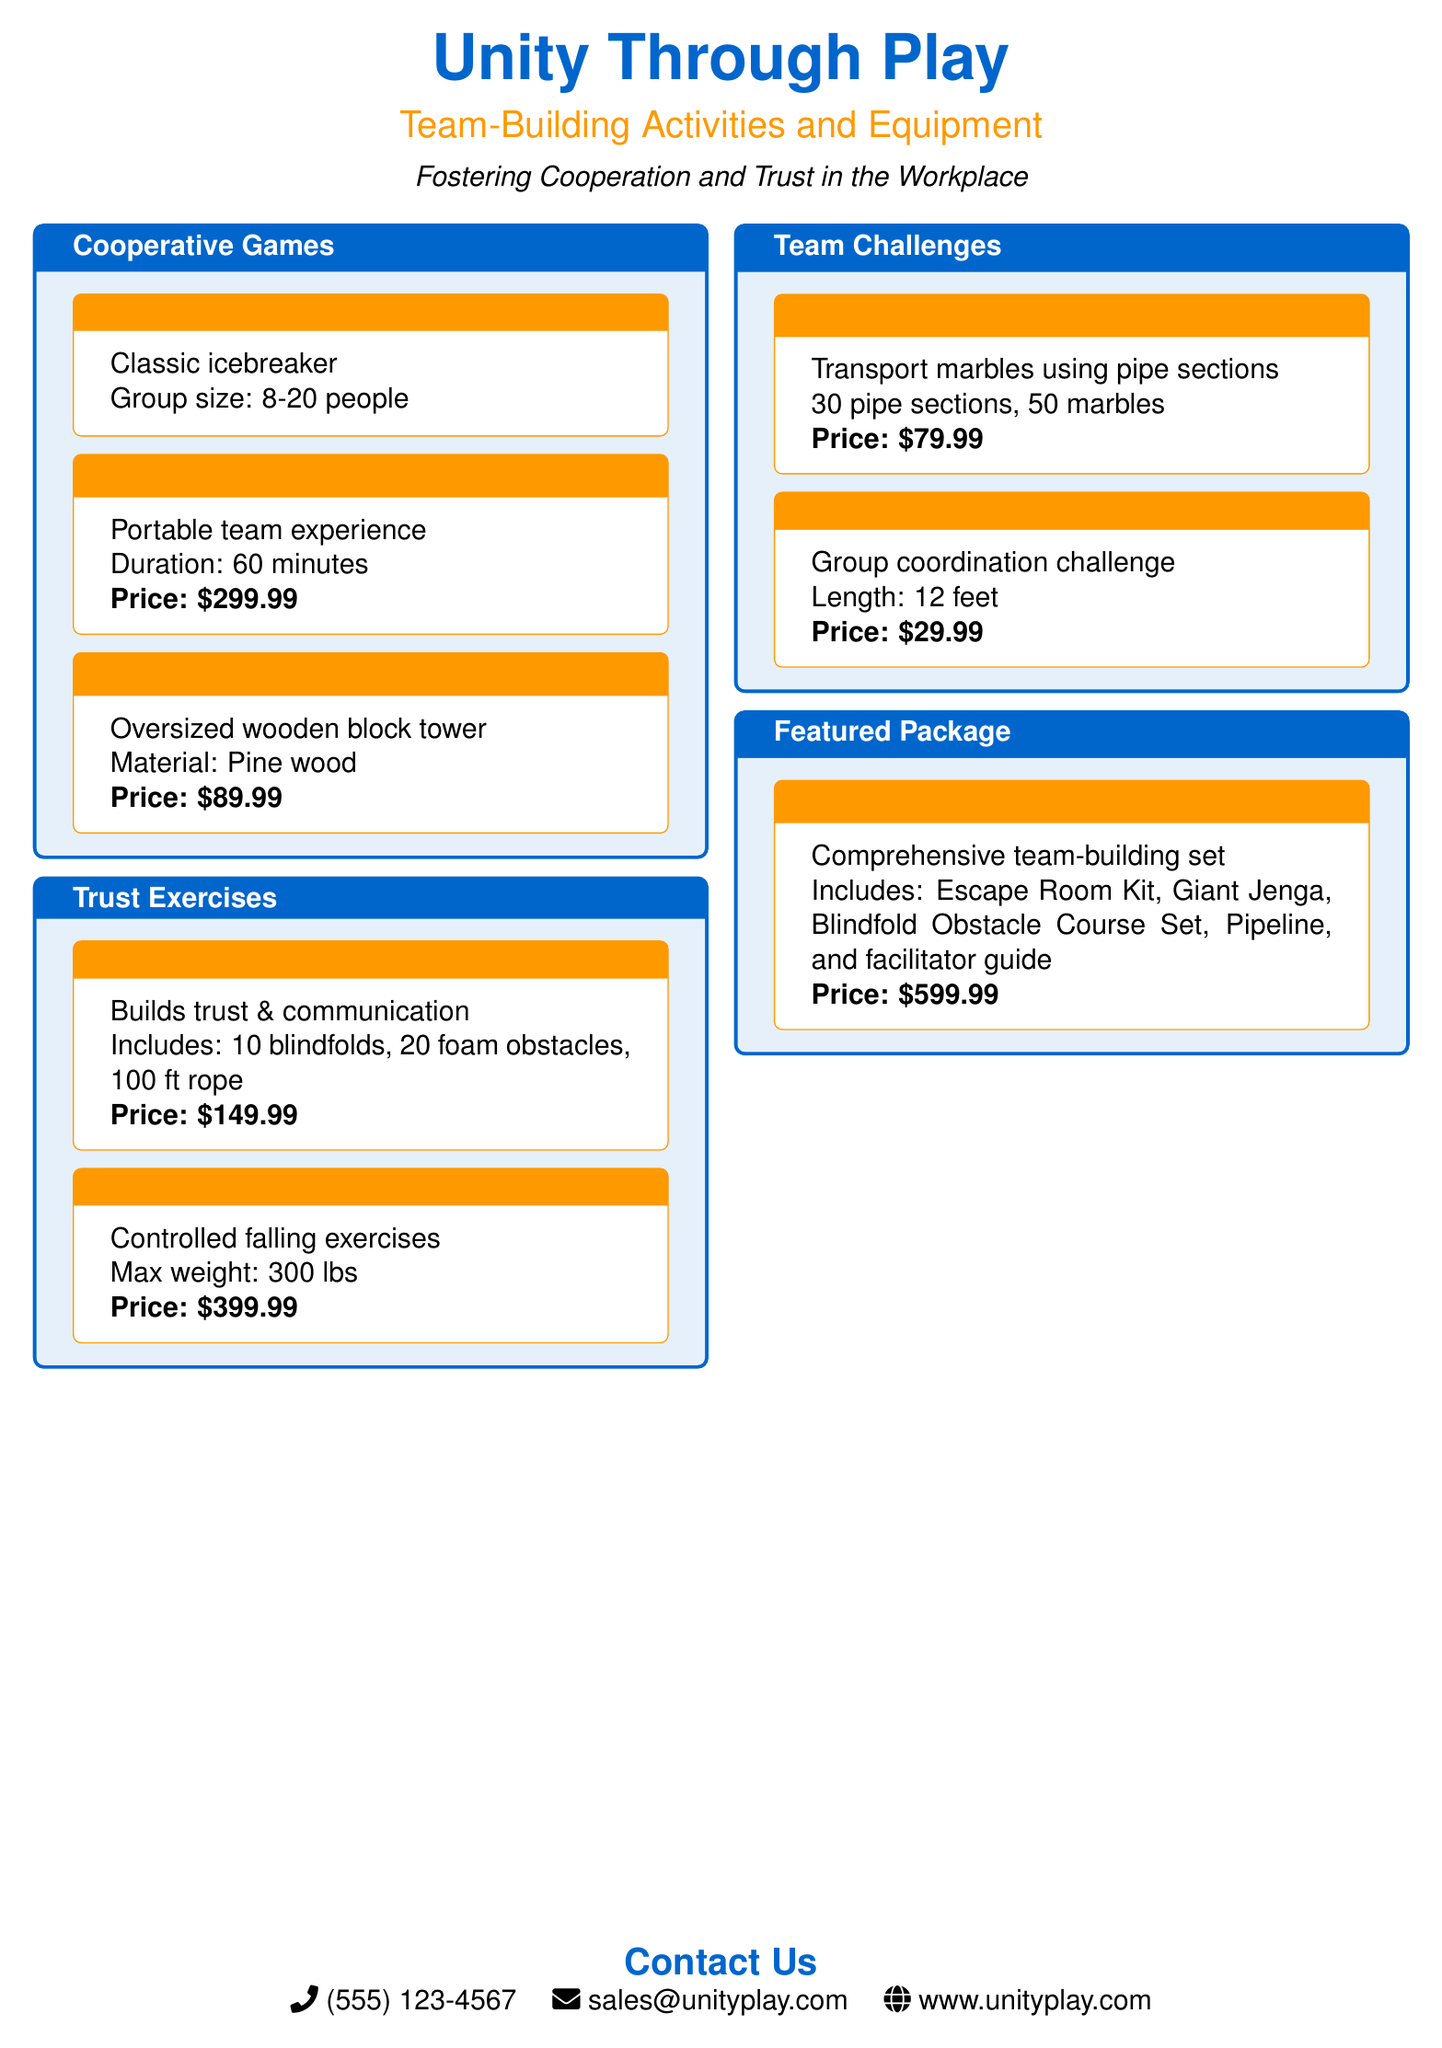What is the cost of the Escape Room Kit? The document lists the price of the Escape Room Kit, which is $299.99.
Answer: $299.99 How many people can participate in the Human Knot game? The document specifies that the recommended group size for the Human Knot is 8-20 people.
Answer: 8-20 people What is included in the Blindfold Obstacle Course Set? The document outlines the components of the Blindfold Obstacle Course Set, which includes 10 blindfolds, 20 foam obstacles, and 100 ft rope.
Answer: 10 blindfolds, 20 foam obstacles, 100 ft rope What is the maximum weight for the Trust Fall Platform? The document states that the maximum weight for the Trust Fall Platform is 300 lbs.
Answer: 300 lbs What is the total price of the Ultimate Team Unity Kit? The document lists the price for the Ultimate Team Unity Kit, which is $599.99.
Answer: $599.99 Which activity is a group coordination challenge? The document identifies the Helium Stick as a group coordination challenge.
Answer: Helium Stick How many marbles are included in the Pipeline challenge? The document indicates that there are 50 marbles included in the Pipeline challenge.
Answer: 50 marbles What type of exercises does the Trust Fall Platform involve? The document describes the Trust Fall Platform as suitable for controlled falling exercises.
Answer: Controlled falling exercises 